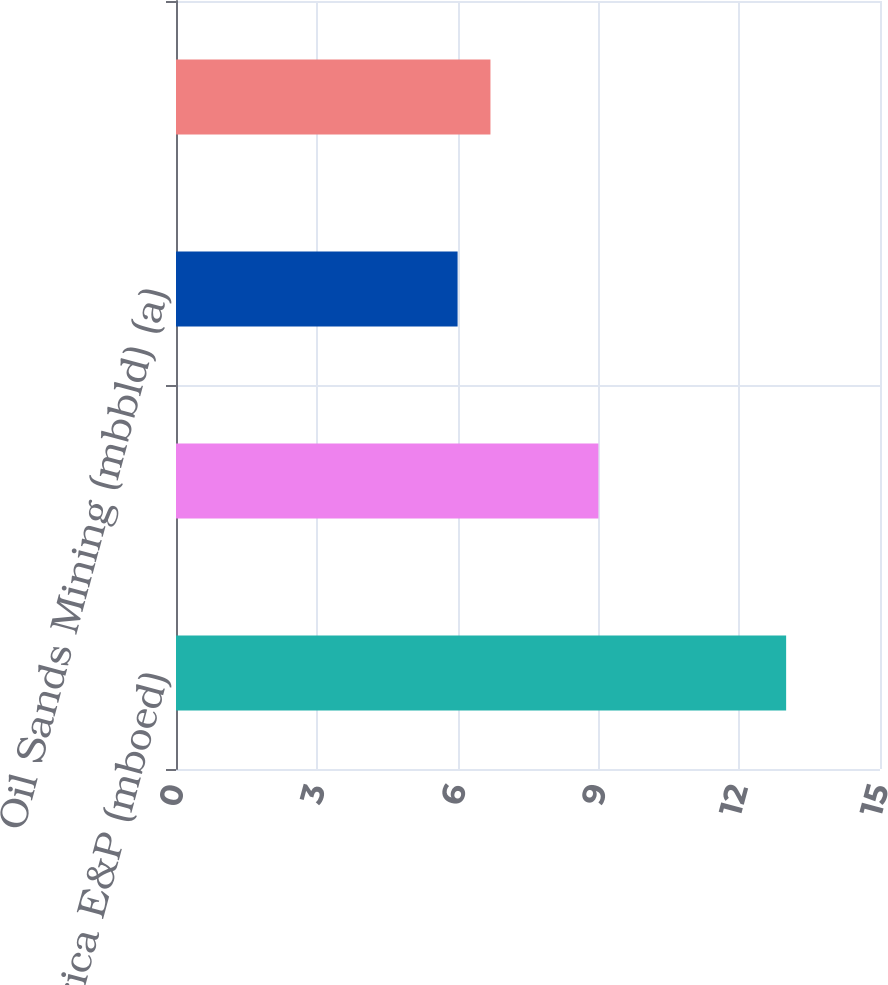Convert chart. <chart><loc_0><loc_0><loc_500><loc_500><bar_chart><fcel>North America E&P (mboed)<fcel>International E&P (mboed)<fcel>Oil Sands Mining (mbbld) (a)<fcel>Total Continuing Operations<nl><fcel>13<fcel>9<fcel>6<fcel>6.7<nl></chart> 